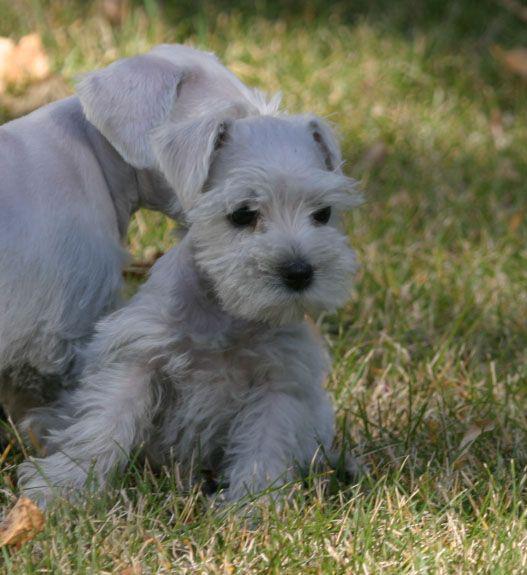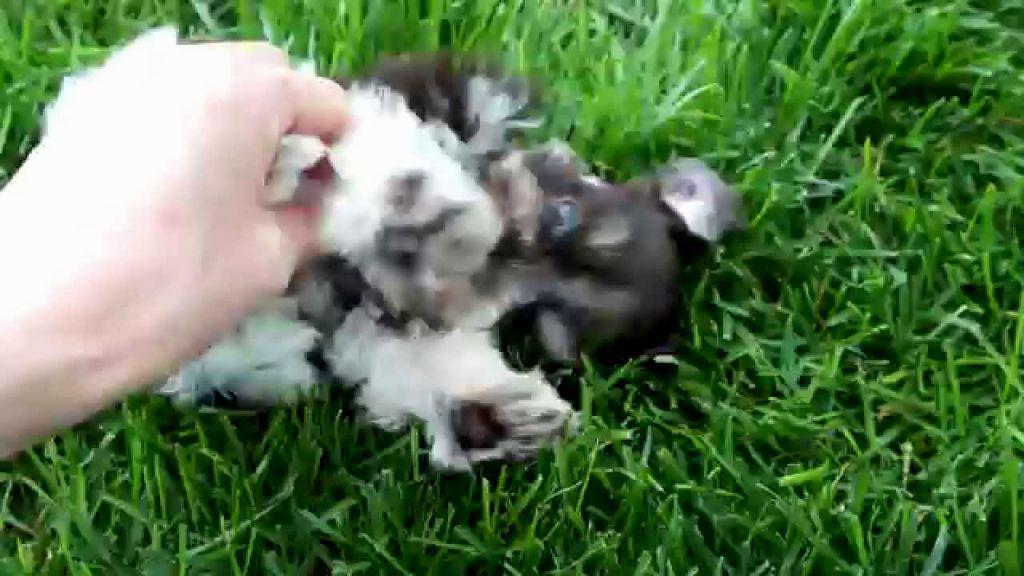The first image is the image on the left, the second image is the image on the right. Analyze the images presented: Is the assertion "An image shows one schnauzer puppy standing in the grass near a toy." valid? Answer yes or no. No. The first image is the image on the left, the second image is the image on the right. Evaluate the accuracy of this statement regarding the images: "A single dog stands in the grass in the image on the right.". Is it true? Answer yes or no. No. 